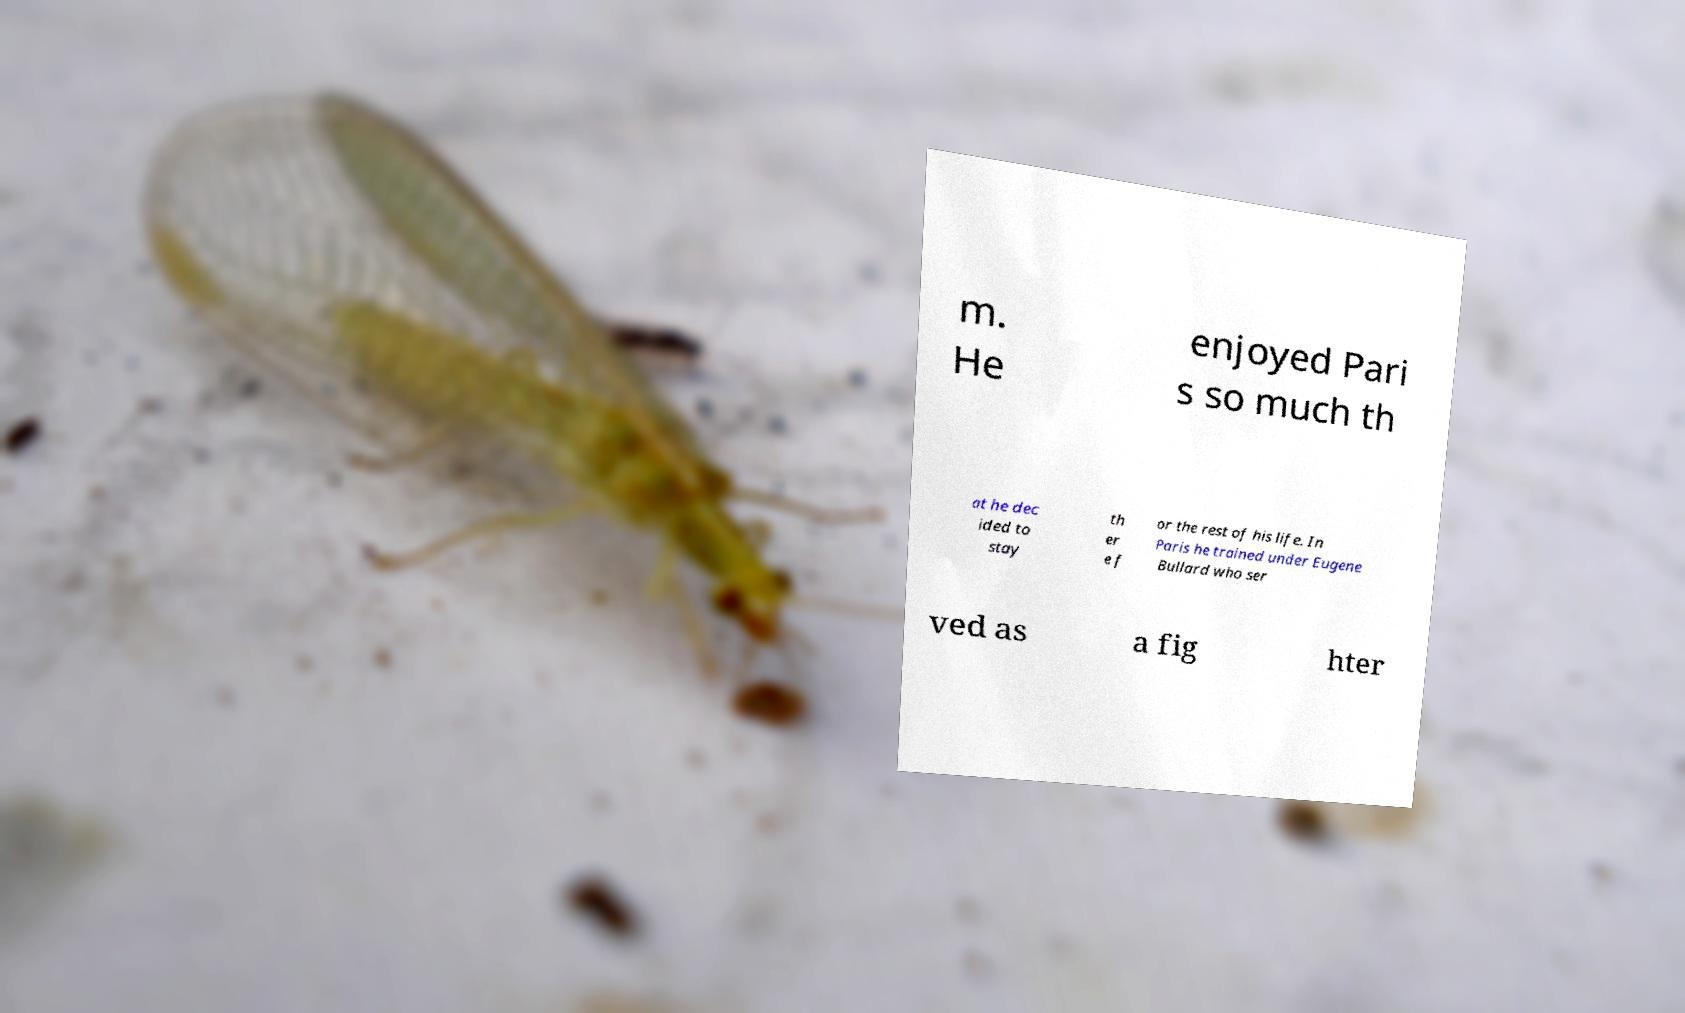What messages or text are displayed in this image? I need them in a readable, typed format. m. He enjoyed Pari s so much th at he dec ided to stay th er e f or the rest of his life. In Paris he trained under Eugene Bullard who ser ved as a fig hter 